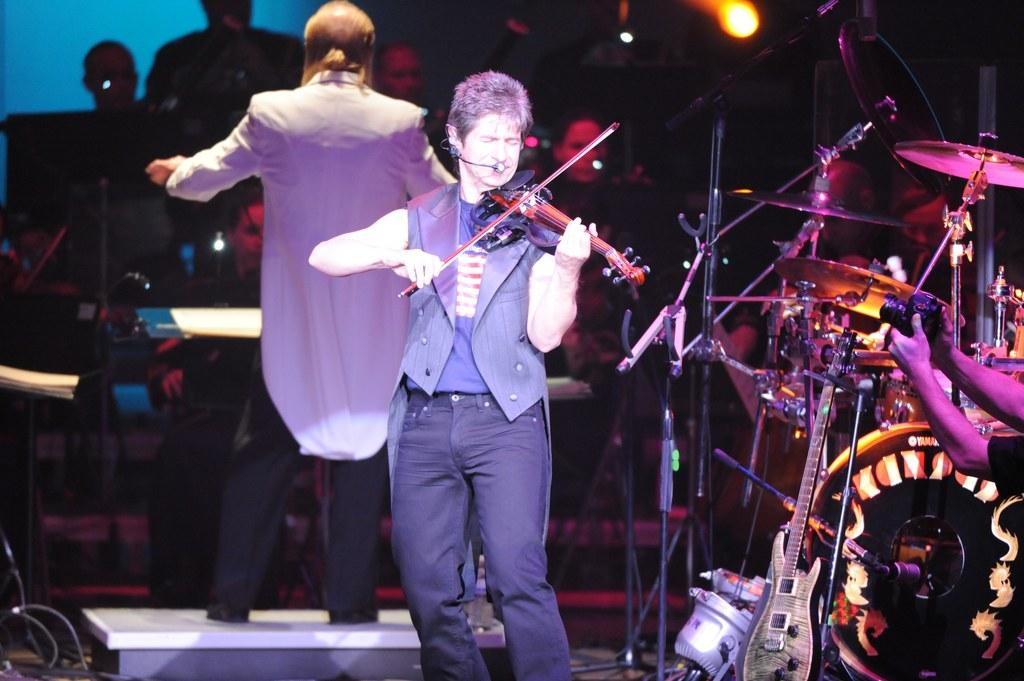What can be seen in the image that provides light? There is a light in the image. What are the people in the image doing? Some people are sitting and standing, and some are playing musical instruments. Can you describe the person holding an object in the image? There is a person holding a camera in the image. What type of mint is being used to flavor the egg in the image? There is no egg or mint present in the image. What type of plough is being used by the person holding a camera in the image? There is no plough present in the image; the person is holding a camera. 